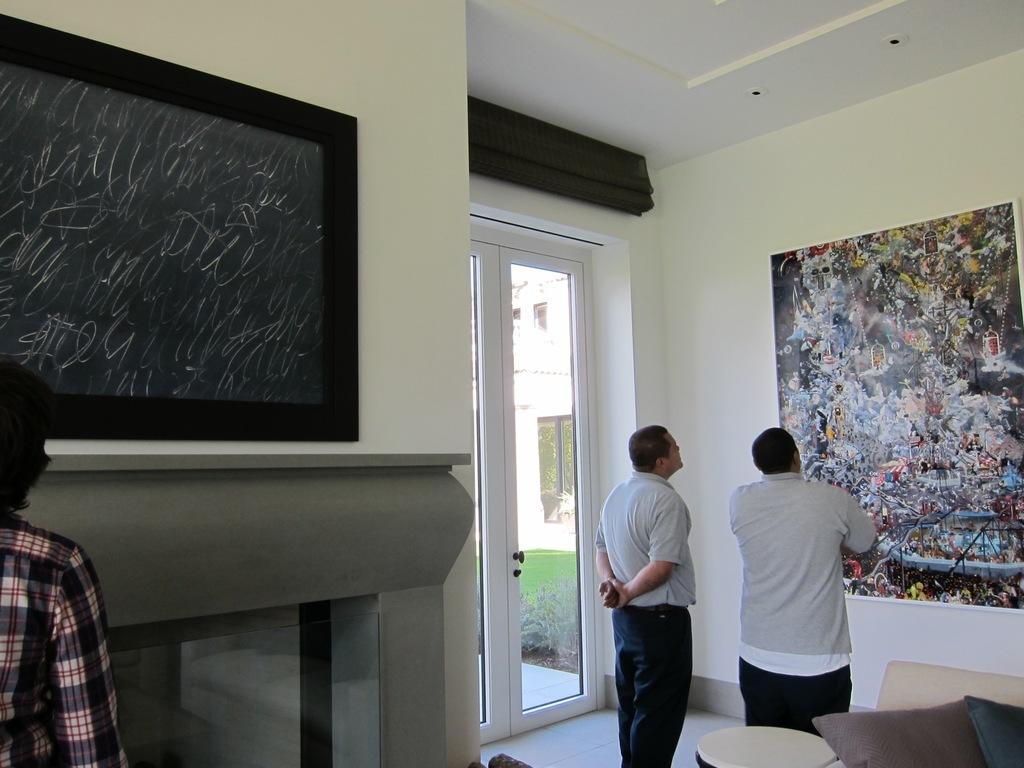Could you give a brief overview of what you see in this image? This is the inside picture of the image. In this image there are three persons standing on the floor. At the center of the image there is a sofa with the pillows on it. There is a glass window and we can see the grass through it. On both right and left side of the image there is a wall with the photo frames on it. 